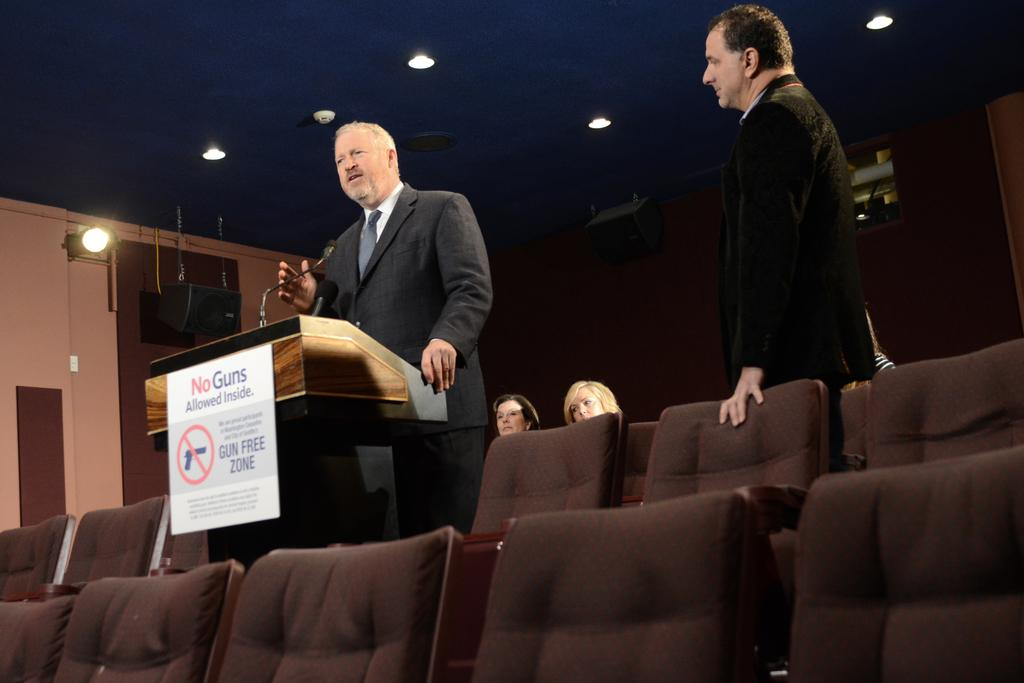What is the man in the image doing? The man is standing behind a wooden stand. How is the other person in the image interacting with the man? The other person is staring at the man. What are the two women in the image doing? The two women are sitting in the image. What furniture is present in the image? Chairs are present in the image. What type of worm can be seen crawling on the wooden stand in the image? There are no worms present in the image; it only features a man standing behind a wooden stand, another person staring at the man, and two women sitting. 